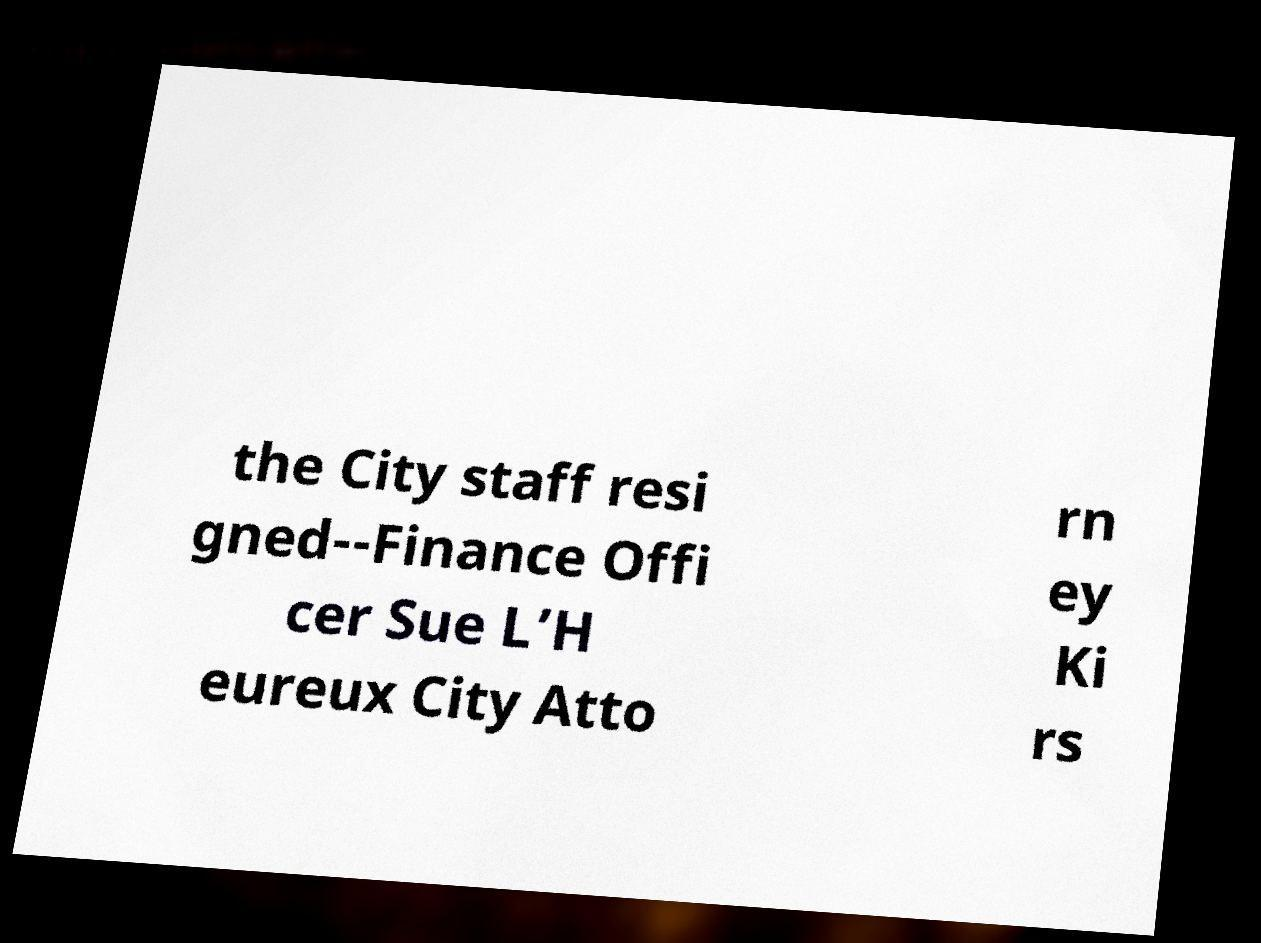Please identify and transcribe the text found in this image. the City staff resi gned--Finance Offi cer Sue L’H eureux City Atto rn ey Ki rs 